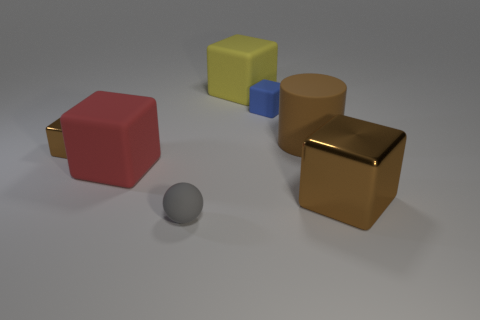There is a big brown thing behind the big red matte block; what material is it?
Offer a very short reply. Rubber. There is a big matte cylinder that is to the left of the big brown object in front of the tiny block on the left side of the blue object; what color is it?
Ensure brevity in your answer.  Brown. There is a cylinder that is the same size as the yellow rubber object; what color is it?
Make the answer very short. Brown. How many shiny objects are either red things or tiny yellow objects?
Your answer should be compact. 0. There is a tiny cube that is made of the same material as the tiny gray ball; what is its color?
Keep it short and to the point. Blue. What is the small thing in front of the brown shiny thing behind the red rubber block made of?
Offer a very short reply. Rubber. How many objects are either tiny gray rubber objects that are in front of the rubber cylinder or big things that are to the right of the yellow block?
Your response must be concise. 3. There is a metallic block right of the tiny rubber object that is behind the object in front of the large brown cube; what size is it?
Offer a very short reply. Large. Are there the same number of rubber blocks in front of the blue matte cube and large rubber objects?
Your response must be concise. No. Is there anything else that is the same shape as the small blue object?
Ensure brevity in your answer.  Yes. 